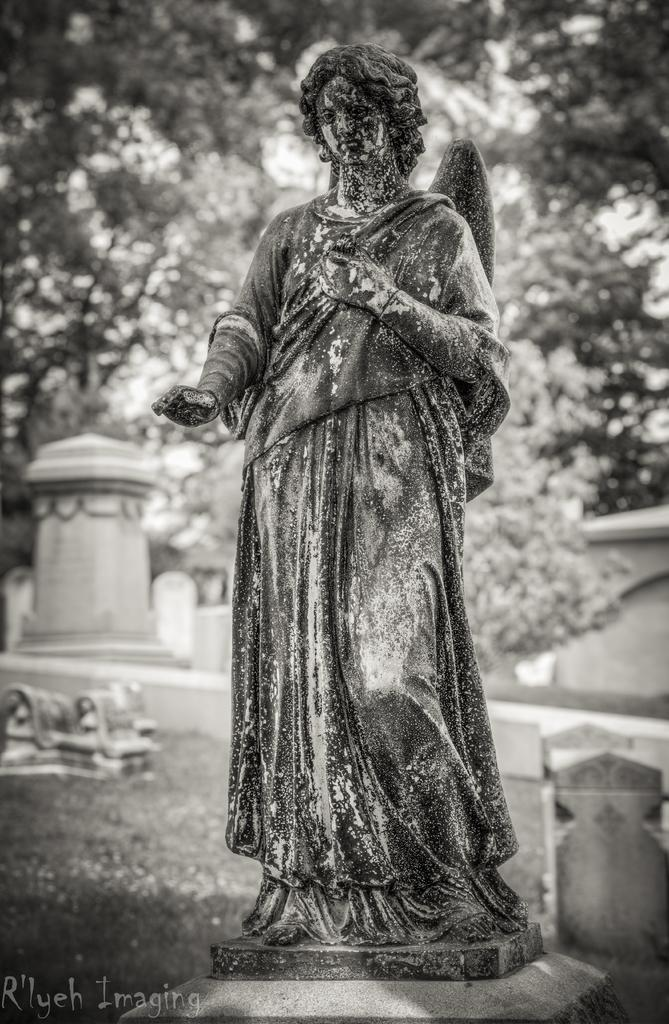What is the main subject in the middle of the image? There is a statue in the middle of the image. What can be seen in the background of the image? There are trees in the background of the image. Is there any text present in the image? Yes, there is some text in the bottom left corner of the image. How many legs does the statue have in the image? The provided facts do not mention the number of legs on the statue, so it cannot be determined from the image. 